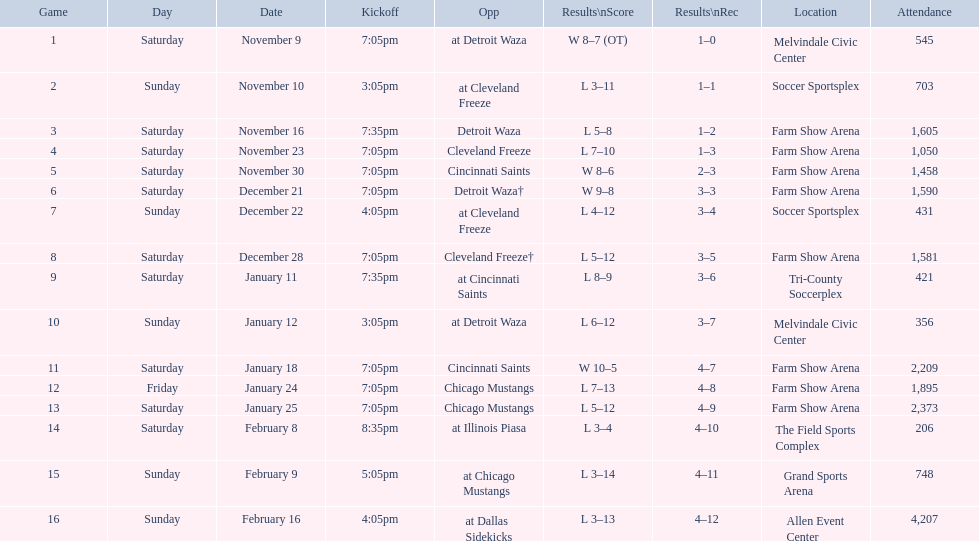What is the date of the game after december 22? December 28. 